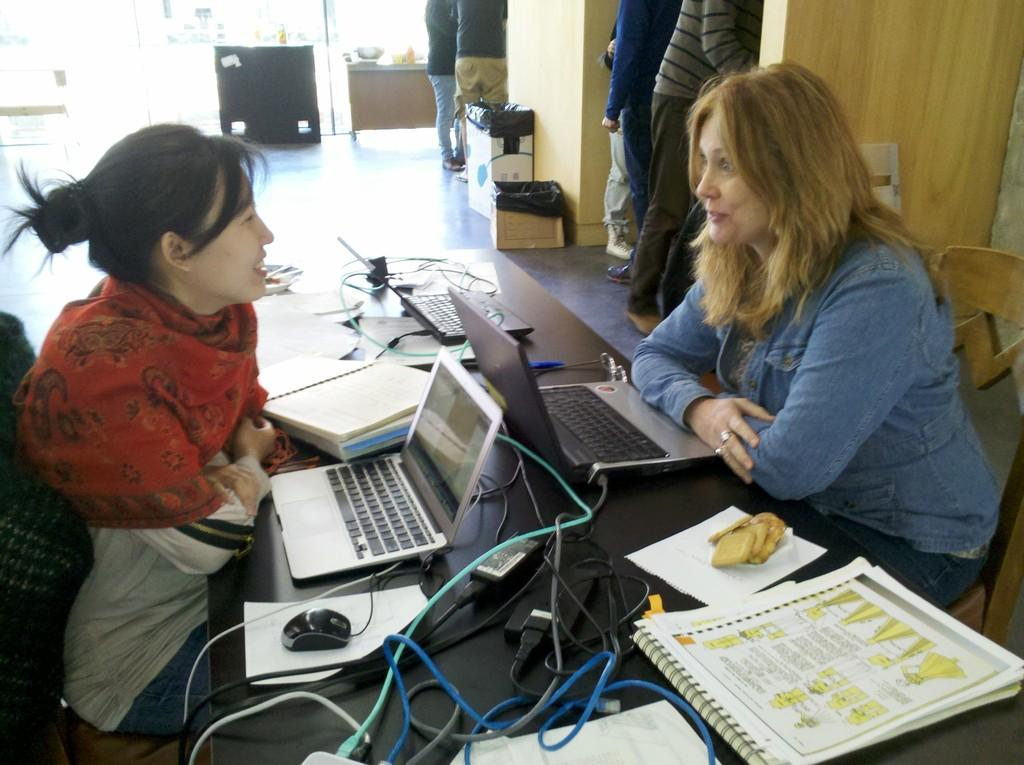How many women are in the image? There are two women in the image. What are the women doing in the image? The women are sitting on chairs. What objects can be seen on the table in the image? There are laptops and books on the table. Can you describe the background of the image? There are people in the background of the image. What type of line is being stitched by the women in the image? There is no line or stitching activity present in the image; the women are sitting with laptops and books on a table. 